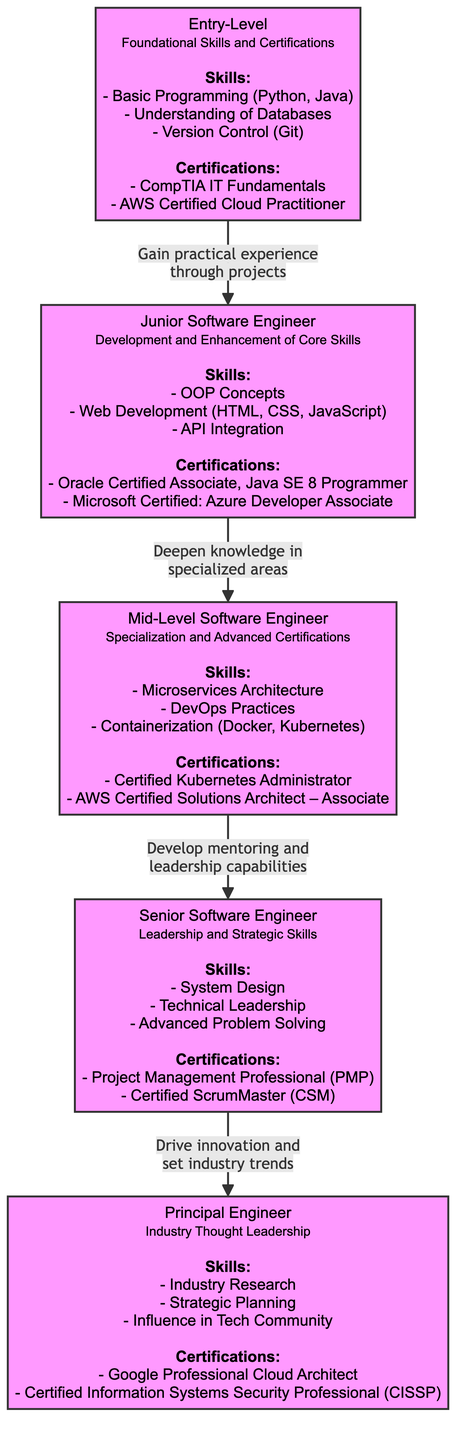What skills are listed for Junior Software Engineer? The diagram shows that the skills listed for Junior Software Engineer include OOP Concepts, Web Development (HTML, CSS, JavaScript), and API Integration. These skills are shown directly under the "Junior Software Engineer" node.
Answer: OOP Concepts, Web Development (HTML, CSS, JavaScript), API Integration What is the certification required for a Senior Software Engineer? According to the diagram, the certifications listed for Senior Software Engineer include Project Management Professional (PMP) and Certified ScrumMaster (CSM). The relevant certifications are presented below the "Senior Software Engineer" node.
Answer: Project Management Professional (PMP), Certified ScrumMaster (CSM) How many levels are there in the career pathway for software engineers? The diagram indicates five levels in the career pathway for software engineers, represented by five distinct nodes connected by arrows, indicating progression from Entry-Level to Principal Engineer.
Answer: Five What is the main focus of the Principal Engineer role? The diagram indicates that the main focus of the Principal Engineer role includes Industry Research, Strategic Planning, and Influence in Tech Community. These are outlined under the Principal Engineer node in the diagram.
Answer: Industry Research, Strategic Planning, Influence in Tech Community What two paths lead to Mid-Level Software Engineer? The diagram indicates that the path to Mid-Level Software Engineer includes gaining practical experience through projects as well as deepening knowledge in specialized areas. This is derived from the flow of arrows leading into the Mid-Level role from both Entry-Level and Junior Software Engineer nodes.
Answer: Gaining practical experience through projects, Deepening knowledge in specialized areas What certifications do you acquire as a Junior Software Engineer? The certifications linked to Junior Software Engineer, as depicted in the diagram, are Oracle Certified Associate, Java SE 8 Programmer and Microsoft Certified: Azure Developer Associate. This information is directly specified under the corresponding node.
Answer: Oracle Certified Associate, Java SE 8 Programmer, Microsoft Certified: Azure Developer Associate Which position emphasizes leadership skills? The diagram indicates that the Senior Software Engineer position emphasizes leadership skills, particularly technical leadership, which is listed under its skills. This can be directly found in the associated node for Senior Software Engineer.
Answer: Senior Software Engineer In what order do the roles progress? The diagram shows the progression order as Entry-Level to Junior Software Engineer to Mid-Level Software Engineer to Senior Software Engineer to Principal Engineer. This sequence is represented by the directional arrows connecting the nodes.
Answer: Entry-Level, Junior Software Engineer, Mid-Level Software Engineer, Senior Software Engineer, Principal Engineer 